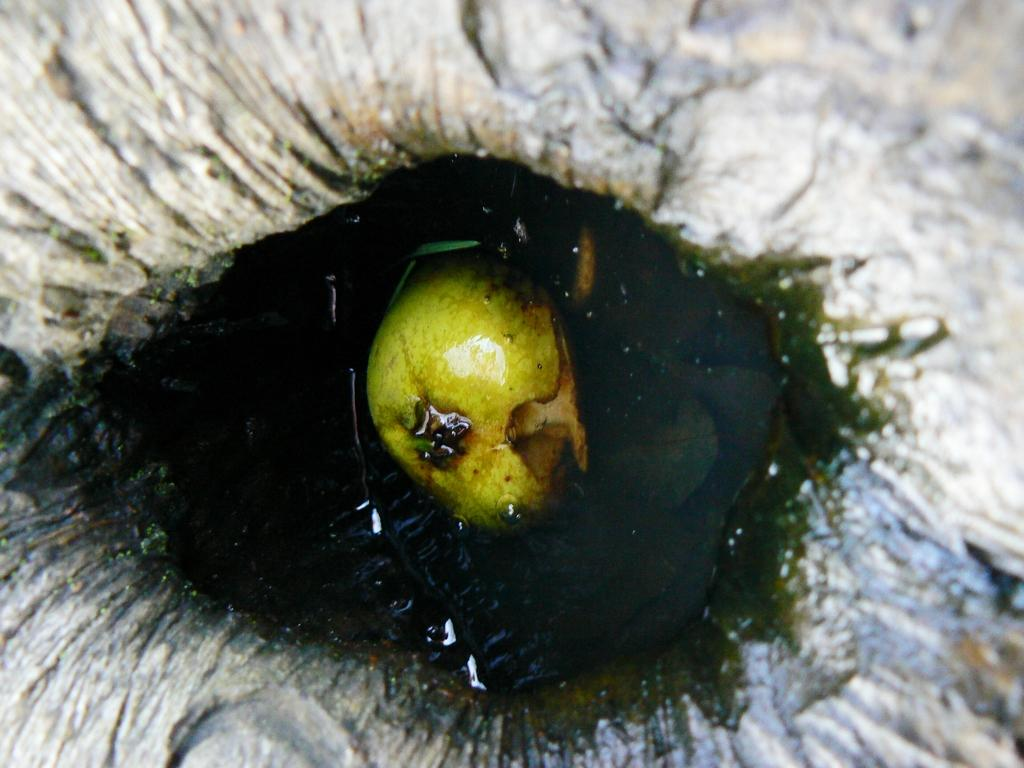What is located in the water in the image? There is an object in the water. What type of cloth is being used to sing songs in the lunchroom in the image? There is no cloth, singing, or lunchroom present in the image; it only features an object in the water. 